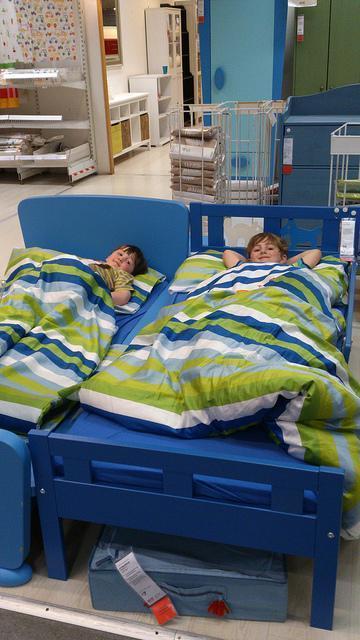How many people are in the picture?
Give a very brief answer. 2. How many beds are there?
Give a very brief answer. 2. 